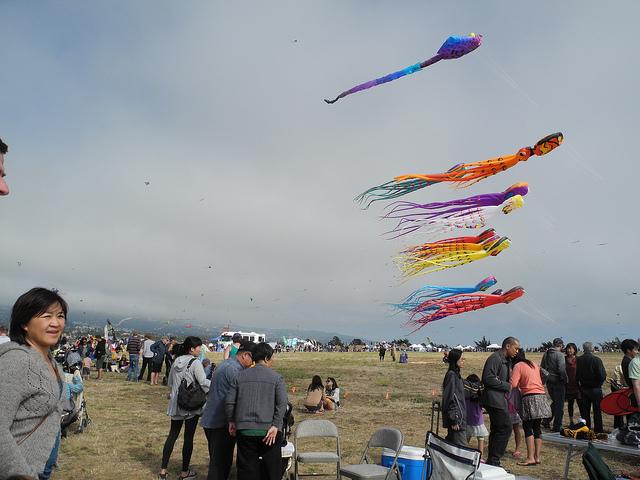What color is the woman on the left wearing?
Concise answer only. Gray. What color are the first 6 kites?
Short answer required. Multiple. How many yellow kites are in the air?
Short answer required. 1. Are they asian?
Concise answer only. Yes. What color is the tent in the back?
Give a very brief answer. White. What are in the air?
Quick response, please. Kites. 